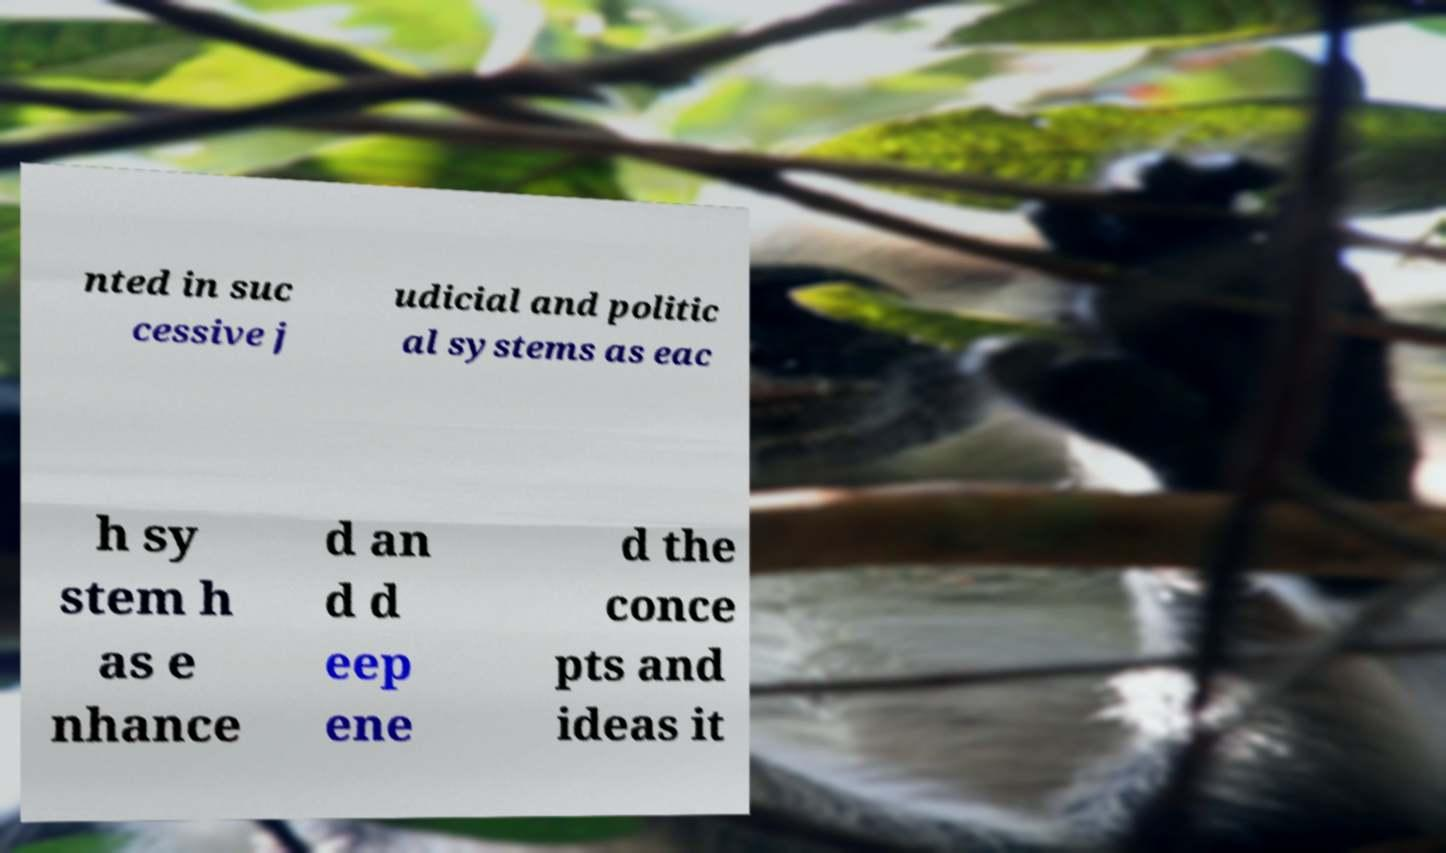Can you read and provide the text displayed in the image?This photo seems to have some interesting text. Can you extract and type it out for me? nted in suc cessive j udicial and politic al systems as eac h sy stem h as e nhance d an d d eep ene d the conce pts and ideas it 